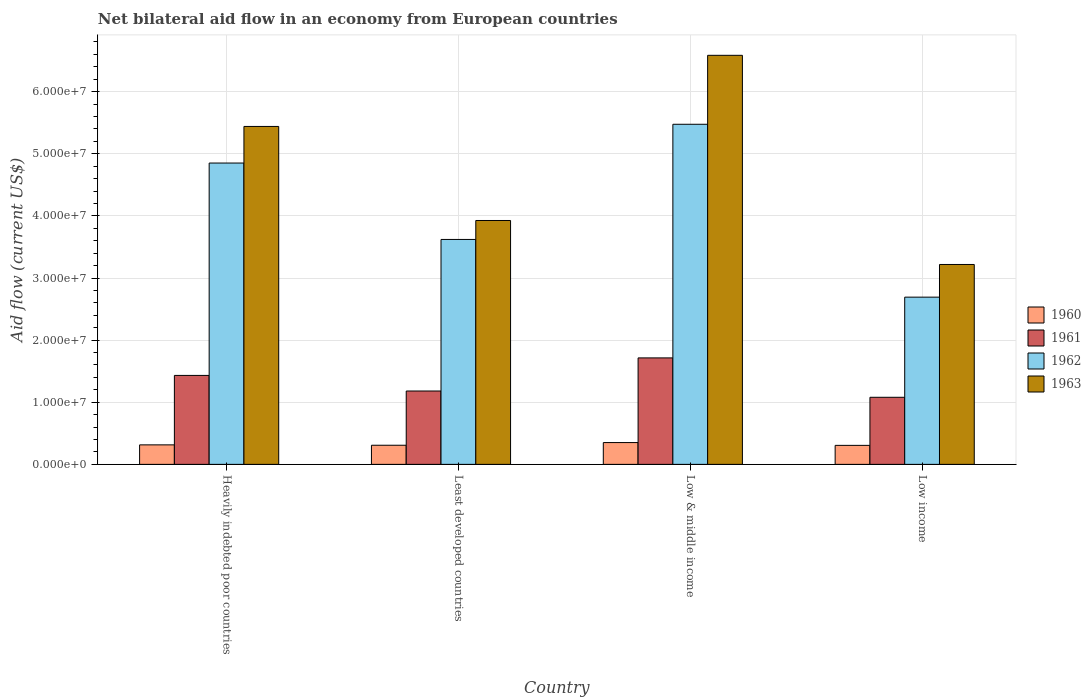Are the number of bars on each tick of the X-axis equal?
Ensure brevity in your answer.  Yes. How many bars are there on the 3rd tick from the left?
Provide a succinct answer. 4. What is the label of the 1st group of bars from the left?
Your answer should be compact. Heavily indebted poor countries. In how many cases, is the number of bars for a given country not equal to the number of legend labels?
Offer a very short reply. 0. What is the net bilateral aid flow in 1962 in Low income?
Offer a terse response. 2.69e+07. Across all countries, what is the maximum net bilateral aid flow in 1963?
Give a very brief answer. 6.58e+07. Across all countries, what is the minimum net bilateral aid flow in 1960?
Your answer should be very brief. 3.06e+06. In which country was the net bilateral aid flow in 1961 minimum?
Your response must be concise. Low income. What is the total net bilateral aid flow in 1962 in the graph?
Make the answer very short. 1.66e+08. What is the difference between the net bilateral aid flow in 1962 in Low income and the net bilateral aid flow in 1963 in Heavily indebted poor countries?
Offer a very short reply. -2.75e+07. What is the average net bilateral aid flow in 1962 per country?
Offer a terse response. 4.16e+07. What is the difference between the net bilateral aid flow of/in 1962 and net bilateral aid flow of/in 1963 in Low & middle income?
Offer a terse response. -1.11e+07. What is the ratio of the net bilateral aid flow in 1961 in Heavily indebted poor countries to that in Low income?
Make the answer very short. 1.33. Is the net bilateral aid flow in 1962 in Least developed countries less than that in Low & middle income?
Your answer should be very brief. Yes. Is the difference between the net bilateral aid flow in 1962 in Least developed countries and Low income greater than the difference between the net bilateral aid flow in 1963 in Least developed countries and Low income?
Provide a succinct answer. Yes. What is the difference between the highest and the second highest net bilateral aid flow in 1961?
Offer a terse response. 2.82e+06. What is the difference between the highest and the lowest net bilateral aid flow in 1961?
Keep it short and to the point. 6.34e+06. In how many countries, is the net bilateral aid flow in 1962 greater than the average net bilateral aid flow in 1962 taken over all countries?
Provide a succinct answer. 2. Is the sum of the net bilateral aid flow in 1961 in Least developed countries and Low & middle income greater than the maximum net bilateral aid flow in 1963 across all countries?
Your answer should be very brief. No. Is it the case that in every country, the sum of the net bilateral aid flow in 1961 and net bilateral aid flow in 1960 is greater than the sum of net bilateral aid flow in 1962 and net bilateral aid flow in 1963?
Offer a very short reply. No. Is it the case that in every country, the sum of the net bilateral aid flow in 1962 and net bilateral aid flow in 1963 is greater than the net bilateral aid flow in 1961?
Your answer should be compact. Yes. Are the values on the major ticks of Y-axis written in scientific E-notation?
Give a very brief answer. Yes. Does the graph contain any zero values?
Offer a very short reply. No. Where does the legend appear in the graph?
Your answer should be very brief. Center right. How many legend labels are there?
Offer a very short reply. 4. How are the legend labels stacked?
Your answer should be very brief. Vertical. What is the title of the graph?
Offer a terse response. Net bilateral aid flow in an economy from European countries. What is the Aid flow (current US$) of 1960 in Heavily indebted poor countries?
Provide a succinct answer. 3.14e+06. What is the Aid flow (current US$) in 1961 in Heavily indebted poor countries?
Your answer should be very brief. 1.43e+07. What is the Aid flow (current US$) in 1962 in Heavily indebted poor countries?
Provide a succinct answer. 4.85e+07. What is the Aid flow (current US$) of 1963 in Heavily indebted poor countries?
Provide a succinct answer. 5.44e+07. What is the Aid flow (current US$) of 1960 in Least developed countries?
Provide a short and direct response. 3.08e+06. What is the Aid flow (current US$) of 1961 in Least developed countries?
Your answer should be very brief. 1.18e+07. What is the Aid flow (current US$) of 1962 in Least developed countries?
Ensure brevity in your answer.  3.62e+07. What is the Aid flow (current US$) of 1963 in Least developed countries?
Make the answer very short. 3.93e+07. What is the Aid flow (current US$) in 1960 in Low & middle income?
Ensure brevity in your answer.  3.51e+06. What is the Aid flow (current US$) of 1961 in Low & middle income?
Keep it short and to the point. 1.71e+07. What is the Aid flow (current US$) in 1962 in Low & middle income?
Your answer should be compact. 5.48e+07. What is the Aid flow (current US$) of 1963 in Low & middle income?
Your response must be concise. 6.58e+07. What is the Aid flow (current US$) in 1960 in Low income?
Your answer should be very brief. 3.06e+06. What is the Aid flow (current US$) in 1961 in Low income?
Make the answer very short. 1.08e+07. What is the Aid flow (current US$) of 1962 in Low income?
Keep it short and to the point. 2.69e+07. What is the Aid flow (current US$) in 1963 in Low income?
Keep it short and to the point. 3.22e+07. Across all countries, what is the maximum Aid flow (current US$) of 1960?
Your response must be concise. 3.51e+06. Across all countries, what is the maximum Aid flow (current US$) of 1961?
Your response must be concise. 1.71e+07. Across all countries, what is the maximum Aid flow (current US$) of 1962?
Your answer should be very brief. 5.48e+07. Across all countries, what is the maximum Aid flow (current US$) in 1963?
Your response must be concise. 6.58e+07. Across all countries, what is the minimum Aid flow (current US$) of 1960?
Your answer should be compact. 3.06e+06. Across all countries, what is the minimum Aid flow (current US$) of 1961?
Your answer should be compact. 1.08e+07. Across all countries, what is the minimum Aid flow (current US$) of 1962?
Your answer should be very brief. 2.69e+07. Across all countries, what is the minimum Aid flow (current US$) in 1963?
Keep it short and to the point. 3.22e+07. What is the total Aid flow (current US$) in 1960 in the graph?
Provide a succinct answer. 1.28e+07. What is the total Aid flow (current US$) in 1961 in the graph?
Your response must be concise. 5.41e+07. What is the total Aid flow (current US$) in 1962 in the graph?
Offer a very short reply. 1.66e+08. What is the total Aid flow (current US$) of 1963 in the graph?
Your answer should be very brief. 1.92e+08. What is the difference between the Aid flow (current US$) of 1960 in Heavily indebted poor countries and that in Least developed countries?
Your answer should be compact. 6.00e+04. What is the difference between the Aid flow (current US$) of 1961 in Heavily indebted poor countries and that in Least developed countries?
Ensure brevity in your answer.  2.51e+06. What is the difference between the Aid flow (current US$) of 1962 in Heavily indebted poor countries and that in Least developed countries?
Give a very brief answer. 1.23e+07. What is the difference between the Aid flow (current US$) of 1963 in Heavily indebted poor countries and that in Least developed countries?
Your response must be concise. 1.51e+07. What is the difference between the Aid flow (current US$) in 1960 in Heavily indebted poor countries and that in Low & middle income?
Keep it short and to the point. -3.70e+05. What is the difference between the Aid flow (current US$) of 1961 in Heavily indebted poor countries and that in Low & middle income?
Your response must be concise. -2.82e+06. What is the difference between the Aid flow (current US$) in 1962 in Heavily indebted poor countries and that in Low & middle income?
Keep it short and to the point. -6.24e+06. What is the difference between the Aid flow (current US$) in 1963 in Heavily indebted poor countries and that in Low & middle income?
Give a very brief answer. -1.14e+07. What is the difference between the Aid flow (current US$) of 1960 in Heavily indebted poor countries and that in Low income?
Offer a very short reply. 8.00e+04. What is the difference between the Aid flow (current US$) of 1961 in Heavily indebted poor countries and that in Low income?
Your answer should be very brief. 3.52e+06. What is the difference between the Aid flow (current US$) of 1962 in Heavily indebted poor countries and that in Low income?
Offer a terse response. 2.16e+07. What is the difference between the Aid flow (current US$) in 1963 in Heavily indebted poor countries and that in Low income?
Offer a very short reply. 2.22e+07. What is the difference between the Aid flow (current US$) of 1960 in Least developed countries and that in Low & middle income?
Offer a very short reply. -4.30e+05. What is the difference between the Aid flow (current US$) of 1961 in Least developed countries and that in Low & middle income?
Ensure brevity in your answer.  -5.33e+06. What is the difference between the Aid flow (current US$) of 1962 in Least developed countries and that in Low & middle income?
Provide a succinct answer. -1.85e+07. What is the difference between the Aid flow (current US$) of 1963 in Least developed countries and that in Low & middle income?
Your answer should be compact. -2.66e+07. What is the difference between the Aid flow (current US$) of 1961 in Least developed countries and that in Low income?
Your response must be concise. 1.01e+06. What is the difference between the Aid flow (current US$) in 1962 in Least developed countries and that in Low income?
Keep it short and to the point. 9.29e+06. What is the difference between the Aid flow (current US$) in 1963 in Least developed countries and that in Low income?
Provide a succinct answer. 7.08e+06. What is the difference between the Aid flow (current US$) of 1961 in Low & middle income and that in Low income?
Offer a terse response. 6.34e+06. What is the difference between the Aid flow (current US$) of 1962 in Low & middle income and that in Low income?
Your response must be concise. 2.78e+07. What is the difference between the Aid flow (current US$) of 1963 in Low & middle income and that in Low income?
Your response must be concise. 3.37e+07. What is the difference between the Aid flow (current US$) of 1960 in Heavily indebted poor countries and the Aid flow (current US$) of 1961 in Least developed countries?
Your answer should be very brief. -8.67e+06. What is the difference between the Aid flow (current US$) of 1960 in Heavily indebted poor countries and the Aid flow (current US$) of 1962 in Least developed countries?
Offer a very short reply. -3.31e+07. What is the difference between the Aid flow (current US$) in 1960 in Heavily indebted poor countries and the Aid flow (current US$) in 1963 in Least developed countries?
Provide a short and direct response. -3.61e+07. What is the difference between the Aid flow (current US$) of 1961 in Heavily indebted poor countries and the Aid flow (current US$) of 1962 in Least developed countries?
Offer a terse response. -2.19e+07. What is the difference between the Aid flow (current US$) in 1961 in Heavily indebted poor countries and the Aid flow (current US$) in 1963 in Least developed countries?
Make the answer very short. -2.49e+07. What is the difference between the Aid flow (current US$) of 1962 in Heavily indebted poor countries and the Aid flow (current US$) of 1963 in Least developed countries?
Keep it short and to the point. 9.25e+06. What is the difference between the Aid flow (current US$) in 1960 in Heavily indebted poor countries and the Aid flow (current US$) in 1961 in Low & middle income?
Your answer should be very brief. -1.40e+07. What is the difference between the Aid flow (current US$) of 1960 in Heavily indebted poor countries and the Aid flow (current US$) of 1962 in Low & middle income?
Your answer should be compact. -5.16e+07. What is the difference between the Aid flow (current US$) of 1960 in Heavily indebted poor countries and the Aid flow (current US$) of 1963 in Low & middle income?
Your answer should be compact. -6.27e+07. What is the difference between the Aid flow (current US$) in 1961 in Heavily indebted poor countries and the Aid flow (current US$) in 1962 in Low & middle income?
Provide a short and direct response. -4.04e+07. What is the difference between the Aid flow (current US$) in 1961 in Heavily indebted poor countries and the Aid flow (current US$) in 1963 in Low & middle income?
Ensure brevity in your answer.  -5.15e+07. What is the difference between the Aid flow (current US$) in 1962 in Heavily indebted poor countries and the Aid flow (current US$) in 1963 in Low & middle income?
Provide a succinct answer. -1.73e+07. What is the difference between the Aid flow (current US$) in 1960 in Heavily indebted poor countries and the Aid flow (current US$) in 1961 in Low income?
Keep it short and to the point. -7.66e+06. What is the difference between the Aid flow (current US$) of 1960 in Heavily indebted poor countries and the Aid flow (current US$) of 1962 in Low income?
Provide a short and direct response. -2.38e+07. What is the difference between the Aid flow (current US$) of 1960 in Heavily indebted poor countries and the Aid flow (current US$) of 1963 in Low income?
Offer a terse response. -2.90e+07. What is the difference between the Aid flow (current US$) of 1961 in Heavily indebted poor countries and the Aid flow (current US$) of 1962 in Low income?
Offer a terse response. -1.26e+07. What is the difference between the Aid flow (current US$) of 1961 in Heavily indebted poor countries and the Aid flow (current US$) of 1963 in Low income?
Make the answer very short. -1.79e+07. What is the difference between the Aid flow (current US$) in 1962 in Heavily indebted poor countries and the Aid flow (current US$) in 1963 in Low income?
Your response must be concise. 1.63e+07. What is the difference between the Aid flow (current US$) of 1960 in Least developed countries and the Aid flow (current US$) of 1961 in Low & middle income?
Your answer should be compact. -1.41e+07. What is the difference between the Aid flow (current US$) in 1960 in Least developed countries and the Aid flow (current US$) in 1962 in Low & middle income?
Offer a very short reply. -5.17e+07. What is the difference between the Aid flow (current US$) in 1960 in Least developed countries and the Aid flow (current US$) in 1963 in Low & middle income?
Make the answer very short. -6.28e+07. What is the difference between the Aid flow (current US$) of 1961 in Least developed countries and the Aid flow (current US$) of 1962 in Low & middle income?
Ensure brevity in your answer.  -4.29e+07. What is the difference between the Aid flow (current US$) of 1961 in Least developed countries and the Aid flow (current US$) of 1963 in Low & middle income?
Provide a short and direct response. -5.40e+07. What is the difference between the Aid flow (current US$) of 1962 in Least developed countries and the Aid flow (current US$) of 1963 in Low & middle income?
Make the answer very short. -2.96e+07. What is the difference between the Aid flow (current US$) in 1960 in Least developed countries and the Aid flow (current US$) in 1961 in Low income?
Make the answer very short. -7.72e+06. What is the difference between the Aid flow (current US$) in 1960 in Least developed countries and the Aid flow (current US$) in 1962 in Low income?
Make the answer very short. -2.38e+07. What is the difference between the Aid flow (current US$) in 1960 in Least developed countries and the Aid flow (current US$) in 1963 in Low income?
Provide a short and direct response. -2.91e+07. What is the difference between the Aid flow (current US$) in 1961 in Least developed countries and the Aid flow (current US$) in 1962 in Low income?
Offer a very short reply. -1.51e+07. What is the difference between the Aid flow (current US$) in 1961 in Least developed countries and the Aid flow (current US$) in 1963 in Low income?
Offer a terse response. -2.04e+07. What is the difference between the Aid flow (current US$) in 1962 in Least developed countries and the Aid flow (current US$) in 1963 in Low income?
Ensure brevity in your answer.  4.03e+06. What is the difference between the Aid flow (current US$) in 1960 in Low & middle income and the Aid flow (current US$) in 1961 in Low income?
Offer a terse response. -7.29e+06. What is the difference between the Aid flow (current US$) of 1960 in Low & middle income and the Aid flow (current US$) of 1962 in Low income?
Offer a terse response. -2.34e+07. What is the difference between the Aid flow (current US$) in 1960 in Low & middle income and the Aid flow (current US$) in 1963 in Low income?
Offer a very short reply. -2.87e+07. What is the difference between the Aid flow (current US$) in 1961 in Low & middle income and the Aid flow (current US$) in 1962 in Low income?
Keep it short and to the point. -9.78e+06. What is the difference between the Aid flow (current US$) in 1961 in Low & middle income and the Aid flow (current US$) in 1963 in Low income?
Give a very brief answer. -1.50e+07. What is the difference between the Aid flow (current US$) in 1962 in Low & middle income and the Aid flow (current US$) in 1963 in Low income?
Your answer should be compact. 2.26e+07. What is the average Aid flow (current US$) of 1960 per country?
Offer a terse response. 3.20e+06. What is the average Aid flow (current US$) in 1961 per country?
Provide a short and direct response. 1.35e+07. What is the average Aid flow (current US$) of 1962 per country?
Provide a short and direct response. 4.16e+07. What is the average Aid flow (current US$) of 1963 per country?
Your answer should be compact. 4.79e+07. What is the difference between the Aid flow (current US$) in 1960 and Aid flow (current US$) in 1961 in Heavily indebted poor countries?
Your response must be concise. -1.12e+07. What is the difference between the Aid flow (current US$) in 1960 and Aid flow (current US$) in 1962 in Heavily indebted poor countries?
Provide a succinct answer. -4.54e+07. What is the difference between the Aid flow (current US$) in 1960 and Aid flow (current US$) in 1963 in Heavily indebted poor countries?
Provide a succinct answer. -5.13e+07. What is the difference between the Aid flow (current US$) in 1961 and Aid flow (current US$) in 1962 in Heavily indebted poor countries?
Provide a short and direct response. -3.42e+07. What is the difference between the Aid flow (current US$) in 1961 and Aid flow (current US$) in 1963 in Heavily indebted poor countries?
Your answer should be compact. -4.01e+07. What is the difference between the Aid flow (current US$) in 1962 and Aid flow (current US$) in 1963 in Heavily indebted poor countries?
Make the answer very short. -5.89e+06. What is the difference between the Aid flow (current US$) in 1960 and Aid flow (current US$) in 1961 in Least developed countries?
Your response must be concise. -8.73e+06. What is the difference between the Aid flow (current US$) of 1960 and Aid flow (current US$) of 1962 in Least developed countries?
Your answer should be very brief. -3.31e+07. What is the difference between the Aid flow (current US$) in 1960 and Aid flow (current US$) in 1963 in Least developed countries?
Provide a succinct answer. -3.62e+07. What is the difference between the Aid flow (current US$) in 1961 and Aid flow (current US$) in 1962 in Least developed countries?
Provide a short and direct response. -2.44e+07. What is the difference between the Aid flow (current US$) in 1961 and Aid flow (current US$) in 1963 in Least developed countries?
Provide a short and direct response. -2.74e+07. What is the difference between the Aid flow (current US$) of 1962 and Aid flow (current US$) of 1963 in Least developed countries?
Give a very brief answer. -3.05e+06. What is the difference between the Aid flow (current US$) of 1960 and Aid flow (current US$) of 1961 in Low & middle income?
Offer a terse response. -1.36e+07. What is the difference between the Aid flow (current US$) in 1960 and Aid flow (current US$) in 1962 in Low & middle income?
Give a very brief answer. -5.12e+07. What is the difference between the Aid flow (current US$) in 1960 and Aid flow (current US$) in 1963 in Low & middle income?
Your answer should be very brief. -6.23e+07. What is the difference between the Aid flow (current US$) of 1961 and Aid flow (current US$) of 1962 in Low & middle income?
Make the answer very short. -3.76e+07. What is the difference between the Aid flow (current US$) in 1961 and Aid flow (current US$) in 1963 in Low & middle income?
Keep it short and to the point. -4.87e+07. What is the difference between the Aid flow (current US$) in 1962 and Aid flow (current US$) in 1963 in Low & middle income?
Ensure brevity in your answer.  -1.11e+07. What is the difference between the Aid flow (current US$) of 1960 and Aid flow (current US$) of 1961 in Low income?
Offer a terse response. -7.74e+06. What is the difference between the Aid flow (current US$) in 1960 and Aid flow (current US$) in 1962 in Low income?
Your answer should be very brief. -2.39e+07. What is the difference between the Aid flow (current US$) of 1960 and Aid flow (current US$) of 1963 in Low income?
Keep it short and to the point. -2.91e+07. What is the difference between the Aid flow (current US$) of 1961 and Aid flow (current US$) of 1962 in Low income?
Give a very brief answer. -1.61e+07. What is the difference between the Aid flow (current US$) in 1961 and Aid flow (current US$) in 1963 in Low income?
Give a very brief answer. -2.14e+07. What is the difference between the Aid flow (current US$) of 1962 and Aid flow (current US$) of 1963 in Low income?
Provide a short and direct response. -5.26e+06. What is the ratio of the Aid flow (current US$) in 1960 in Heavily indebted poor countries to that in Least developed countries?
Keep it short and to the point. 1.02. What is the ratio of the Aid flow (current US$) in 1961 in Heavily indebted poor countries to that in Least developed countries?
Provide a short and direct response. 1.21. What is the ratio of the Aid flow (current US$) of 1962 in Heavily indebted poor countries to that in Least developed countries?
Keep it short and to the point. 1.34. What is the ratio of the Aid flow (current US$) in 1963 in Heavily indebted poor countries to that in Least developed countries?
Offer a terse response. 1.39. What is the ratio of the Aid flow (current US$) of 1960 in Heavily indebted poor countries to that in Low & middle income?
Provide a succinct answer. 0.89. What is the ratio of the Aid flow (current US$) in 1961 in Heavily indebted poor countries to that in Low & middle income?
Give a very brief answer. 0.84. What is the ratio of the Aid flow (current US$) in 1962 in Heavily indebted poor countries to that in Low & middle income?
Offer a terse response. 0.89. What is the ratio of the Aid flow (current US$) of 1963 in Heavily indebted poor countries to that in Low & middle income?
Keep it short and to the point. 0.83. What is the ratio of the Aid flow (current US$) in 1960 in Heavily indebted poor countries to that in Low income?
Keep it short and to the point. 1.03. What is the ratio of the Aid flow (current US$) in 1961 in Heavily indebted poor countries to that in Low income?
Keep it short and to the point. 1.33. What is the ratio of the Aid flow (current US$) of 1962 in Heavily indebted poor countries to that in Low income?
Offer a terse response. 1.8. What is the ratio of the Aid flow (current US$) of 1963 in Heavily indebted poor countries to that in Low income?
Give a very brief answer. 1.69. What is the ratio of the Aid flow (current US$) of 1960 in Least developed countries to that in Low & middle income?
Provide a short and direct response. 0.88. What is the ratio of the Aid flow (current US$) of 1961 in Least developed countries to that in Low & middle income?
Provide a short and direct response. 0.69. What is the ratio of the Aid flow (current US$) in 1962 in Least developed countries to that in Low & middle income?
Ensure brevity in your answer.  0.66. What is the ratio of the Aid flow (current US$) of 1963 in Least developed countries to that in Low & middle income?
Offer a very short reply. 0.6. What is the ratio of the Aid flow (current US$) in 1961 in Least developed countries to that in Low income?
Provide a short and direct response. 1.09. What is the ratio of the Aid flow (current US$) of 1962 in Least developed countries to that in Low income?
Your response must be concise. 1.35. What is the ratio of the Aid flow (current US$) in 1963 in Least developed countries to that in Low income?
Keep it short and to the point. 1.22. What is the ratio of the Aid flow (current US$) of 1960 in Low & middle income to that in Low income?
Make the answer very short. 1.15. What is the ratio of the Aid flow (current US$) of 1961 in Low & middle income to that in Low income?
Keep it short and to the point. 1.59. What is the ratio of the Aid flow (current US$) in 1962 in Low & middle income to that in Low income?
Your answer should be very brief. 2.03. What is the ratio of the Aid flow (current US$) of 1963 in Low & middle income to that in Low income?
Make the answer very short. 2.05. What is the difference between the highest and the second highest Aid flow (current US$) of 1961?
Make the answer very short. 2.82e+06. What is the difference between the highest and the second highest Aid flow (current US$) in 1962?
Give a very brief answer. 6.24e+06. What is the difference between the highest and the second highest Aid flow (current US$) in 1963?
Your answer should be compact. 1.14e+07. What is the difference between the highest and the lowest Aid flow (current US$) of 1961?
Ensure brevity in your answer.  6.34e+06. What is the difference between the highest and the lowest Aid flow (current US$) of 1962?
Keep it short and to the point. 2.78e+07. What is the difference between the highest and the lowest Aid flow (current US$) of 1963?
Keep it short and to the point. 3.37e+07. 